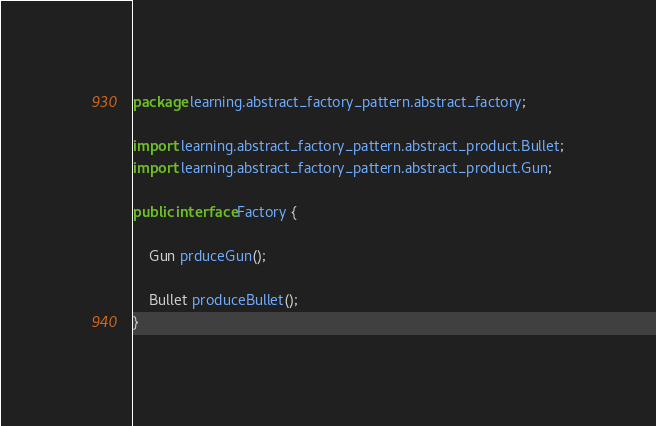<code> <loc_0><loc_0><loc_500><loc_500><_Java_>package learning.abstract_factory_pattern.abstract_factory;

import learning.abstract_factory_pattern.abstract_product.Bullet;
import learning.abstract_factory_pattern.abstract_product.Gun;

public interface Factory {

    Gun prduceGun();

    Bullet produceBullet();
}
</code> 